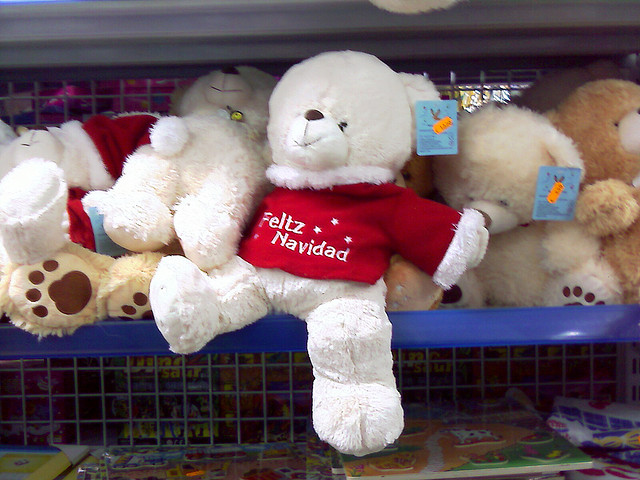Can you tell if the bear is designed for a specific age group? While I can't determine the specific age group just from the image, the teddy bear looks like a classic stuffed toy that people often associate with young children. Given its prominent display and cheerful attire, it's likely suitable for a wide range of ages, particularly as a cuddly companion or decorative gift for the holidays. 